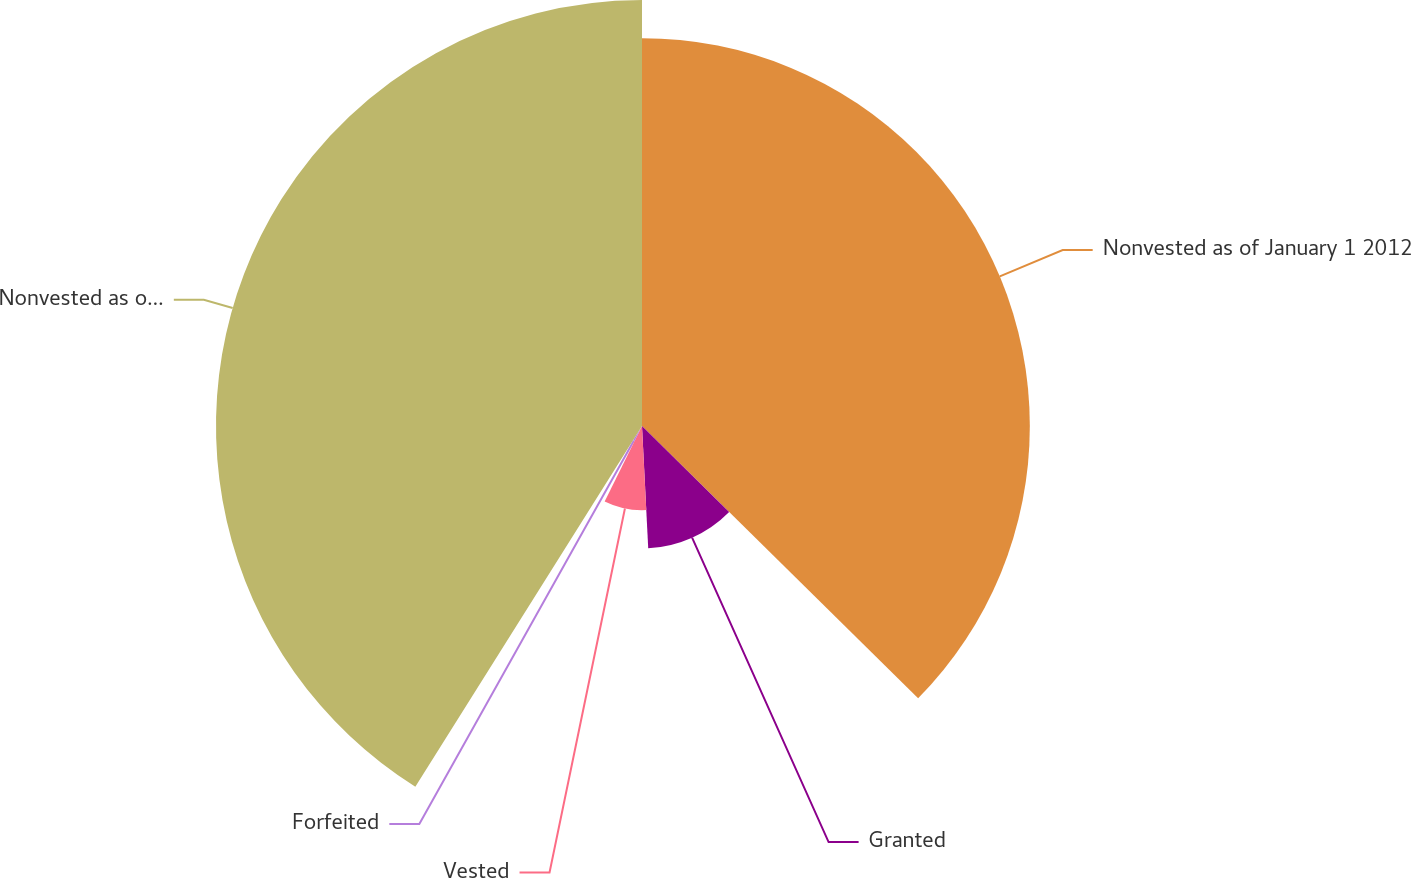Convert chart to OTSL. <chart><loc_0><loc_0><loc_500><loc_500><pie_chart><fcel>Nonvested as of January 1 2012<fcel>Granted<fcel>Vested<fcel>Forfeited<fcel>Nonvested as of December 31<nl><fcel>37.39%<fcel>11.8%<fcel>8.12%<fcel>1.62%<fcel>41.07%<nl></chart> 